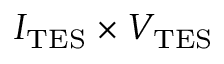<formula> <loc_0><loc_0><loc_500><loc_500>I _ { T E S } \times V _ { T E S }</formula> 